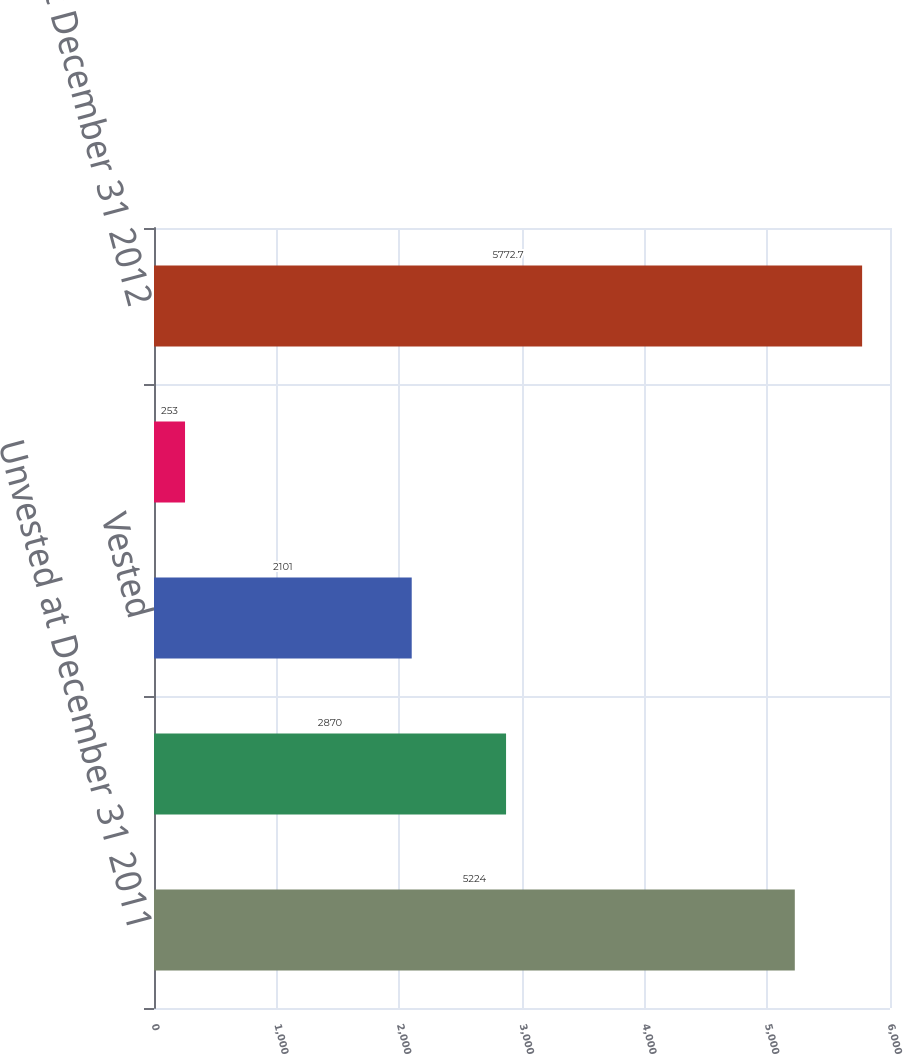Convert chart to OTSL. <chart><loc_0><loc_0><loc_500><loc_500><bar_chart><fcel>Unvested at December 31 2011<fcel>Granted<fcel>Vested<fcel>Forfeited<fcel>Unvested at December 31 2012<nl><fcel>5224<fcel>2870<fcel>2101<fcel>253<fcel>5772.7<nl></chart> 